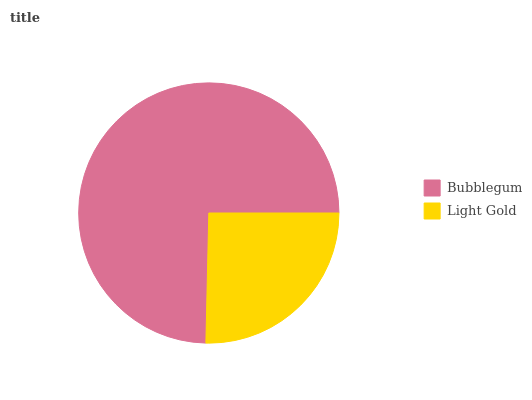Is Light Gold the minimum?
Answer yes or no. Yes. Is Bubblegum the maximum?
Answer yes or no. Yes. Is Light Gold the maximum?
Answer yes or no. No. Is Bubblegum greater than Light Gold?
Answer yes or no. Yes. Is Light Gold less than Bubblegum?
Answer yes or no. Yes. Is Light Gold greater than Bubblegum?
Answer yes or no. No. Is Bubblegum less than Light Gold?
Answer yes or no. No. Is Bubblegum the high median?
Answer yes or no. Yes. Is Light Gold the low median?
Answer yes or no. Yes. Is Light Gold the high median?
Answer yes or no. No. Is Bubblegum the low median?
Answer yes or no. No. 